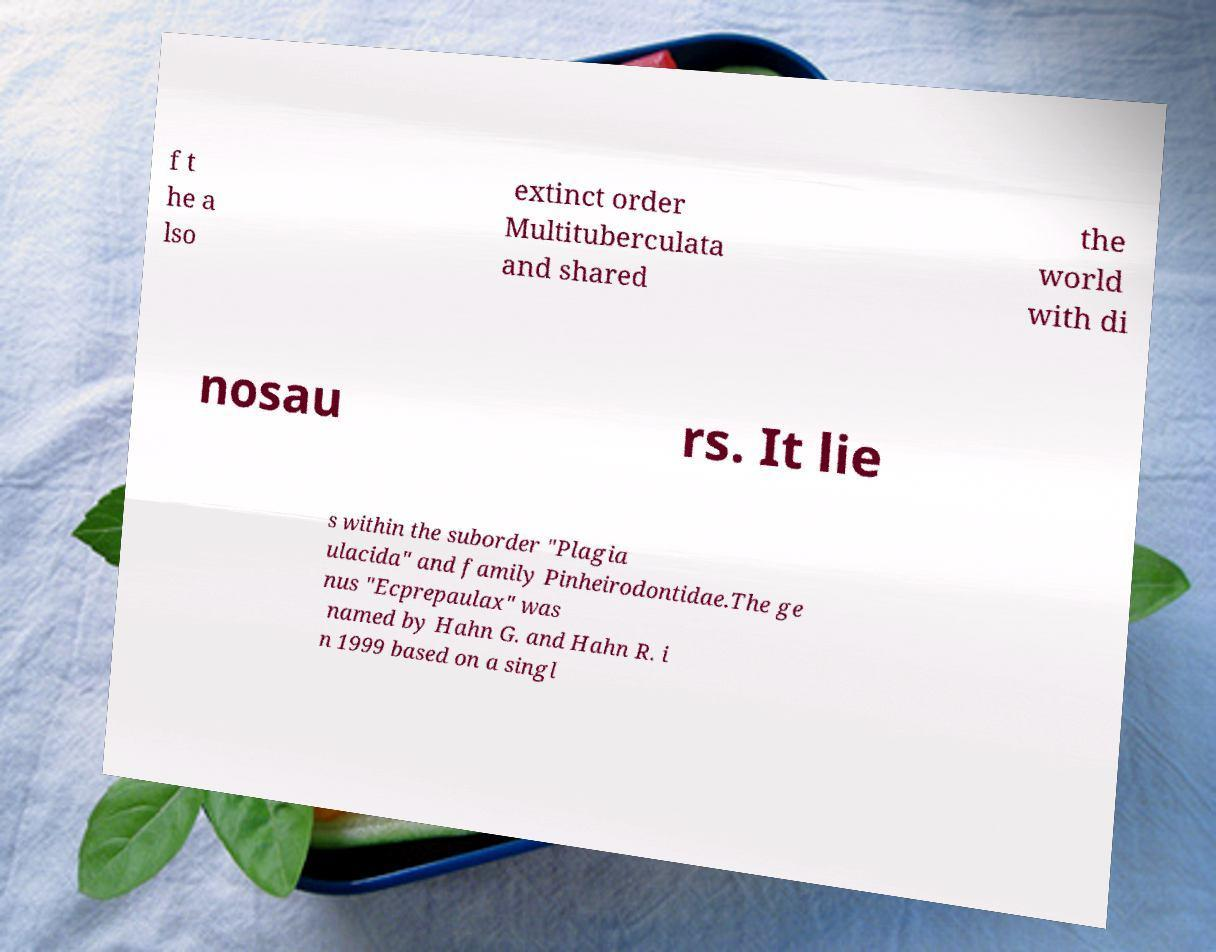For documentation purposes, I need the text within this image transcribed. Could you provide that? f t he a lso extinct order Multituberculata and shared the world with di nosau rs. It lie s within the suborder "Plagia ulacida" and family Pinheirodontidae.The ge nus "Ecprepaulax" was named by Hahn G. and Hahn R. i n 1999 based on a singl 